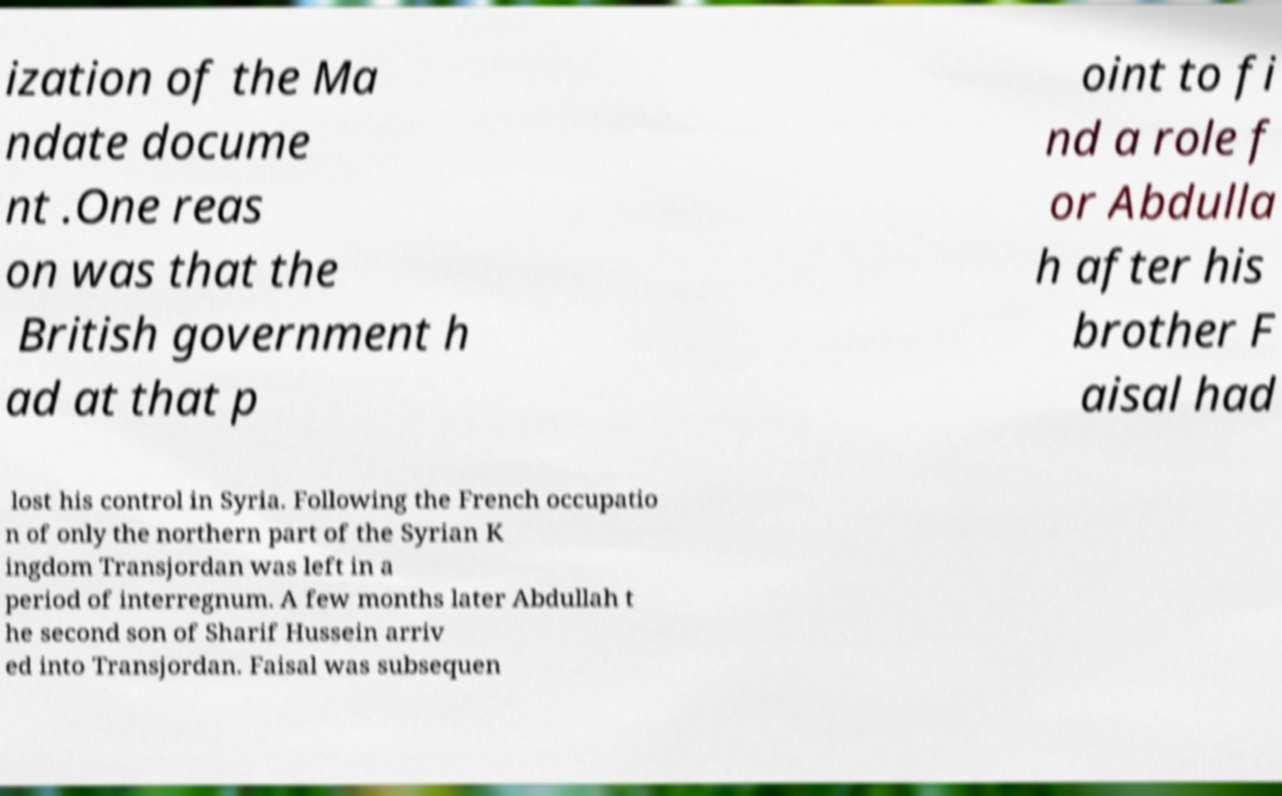For documentation purposes, I need the text within this image transcribed. Could you provide that? ization of the Ma ndate docume nt .One reas on was that the British government h ad at that p oint to fi nd a role f or Abdulla h after his brother F aisal had lost his control in Syria. Following the French occupatio n of only the northern part of the Syrian K ingdom Transjordan was left in a period of interregnum. A few months later Abdullah t he second son of Sharif Hussein arriv ed into Transjordan. Faisal was subsequen 